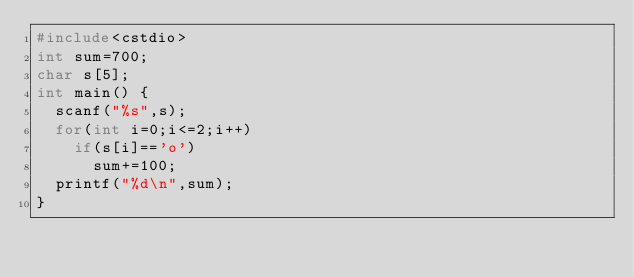Convert code to text. <code><loc_0><loc_0><loc_500><loc_500><_C++_>#include<cstdio>
int sum=700;
char s[5];
int main() {
	scanf("%s",s);
	for(int i=0;i<=2;i++)
		if(s[i]=='o')
			sum+=100;
	printf("%d\n",sum);
}</code> 